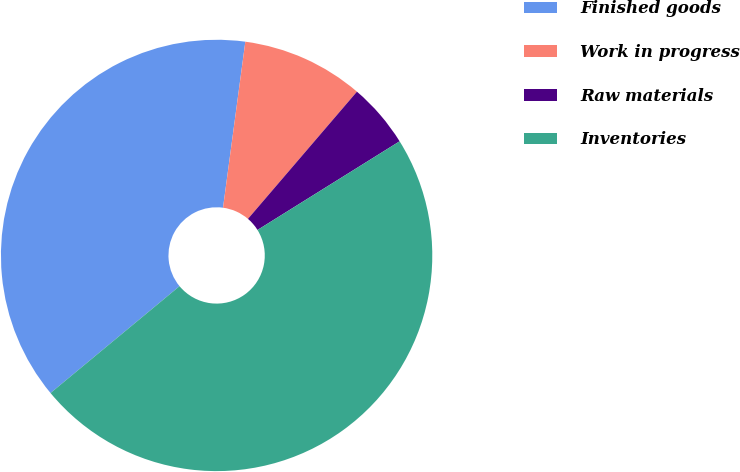Convert chart to OTSL. <chart><loc_0><loc_0><loc_500><loc_500><pie_chart><fcel>Finished goods<fcel>Work in progress<fcel>Raw materials<fcel>Inventories<nl><fcel>38.14%<fcel>9.15%<fcel>4.85%<fcel>47.87%<nl></chart> 